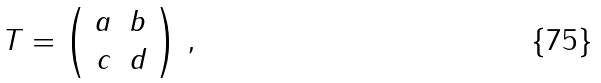Convert formula to latex. <formula><loc_0><loc_0><loc_500><loc_500>T = \left ( \begin{array} { c c } a & b \\ c & d \\ \end{array} \right ) \, ,</formula> 